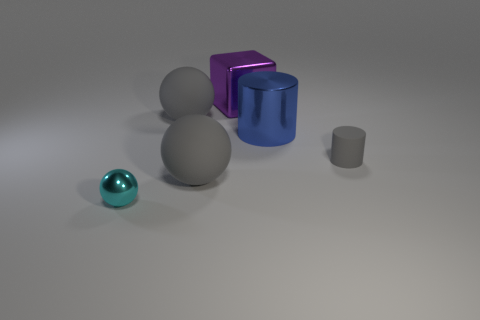Subtract all tiny cyan spheres. How many spheres are left? 2 Subtract all gray cubes. How many gray balls are left? 2 Subtract all cyan balls. How many balls are left? 2 Add 2 big green matte spheres. How many objects exist? 8 Subtract 1 cylinders. How many cylinders are left? 1 Subtract all cubes. How many objects are left? 5 Add 6 large shiny blocks. How many large shiny blocks exist? 7 Subtract 0 gray cubes. How many objects are left? 6 Subtract all blue cubes. Subtract all purple balls. How many cubes are left? 1 Subtract all gray objects. Subtract all purple shiny cylinders. How many objects are left? 3 